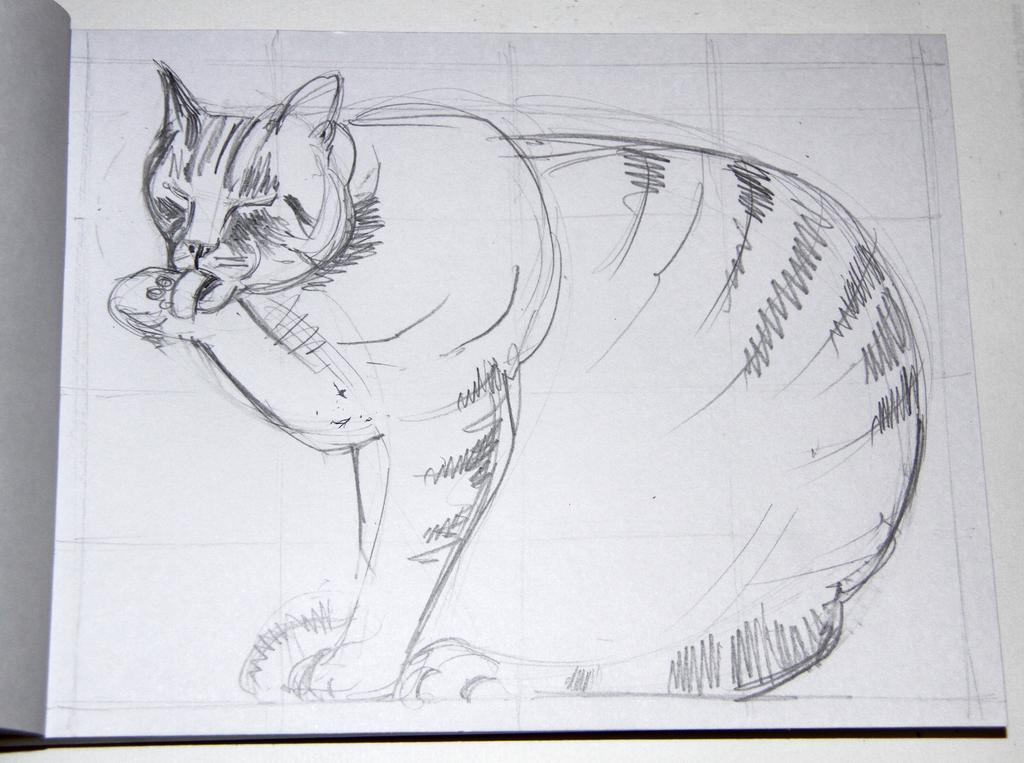What is depicted on the paper in the image? The paper has a drawing of a cat on it. What is the paper placed on in the image? The paper is placed on an object. How many fish are swimming in the drawing of the cat on the paper? There are no fish depicted in the drawing of the cat on the paper. 